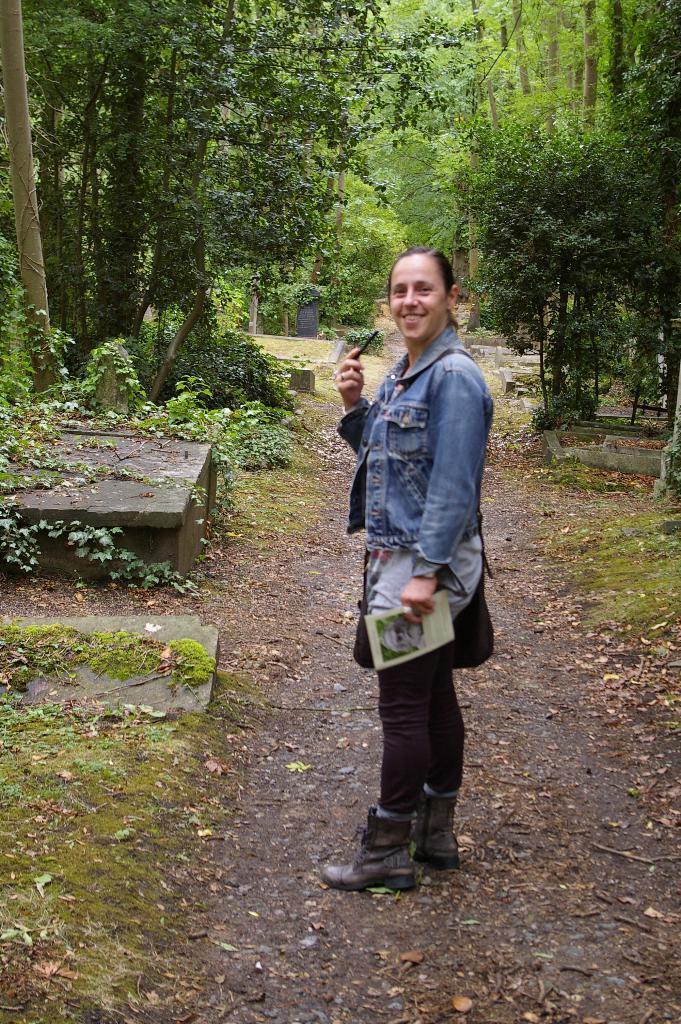Could you give a brief overview of what you see in this image? In this image I can see a woman is standing. I can see she is holding a phone, a paper and I can see she is carrying a bag. I can also see smile on her face and I can see she is wearing blue colour jacket, pant and shoes. In background I can see grass and number of trees. 